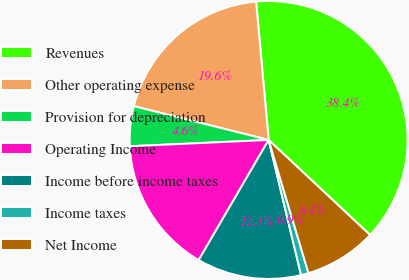Convert chart. <chart><loc_0><loc_0><loc_500><loc_500><pie_chart><fcel>Revenues<fcel>Other operating expense<fcel>Provision for depreciation<fcel>Operating Income<fcel>Income before income taxes<fcel>Income taxes<fcel>Net Income<nl><fcel>38.42%<fcel>19.65%<fcel>4.63%<fcel>15.89%<fcel>12.14%<fcel>0.88%<fcel>8.39%<nl></chart> 